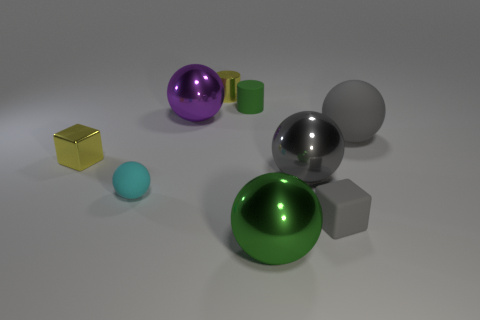What number of other objects are there of the same material as the big green sphere?
Your answer should be compact. 4. Do the big metallic object to the left of the large green shiny thing and the large object that is in front of the big gray shiny sphere have the same shape?
Your answer should be very brief. Yes. What is the color of the tiny cube to the right of the yellow shiny thing that is in front of the tiny cylinder that is behind the matte cylinder?
Give a very brief answer. Gray. What number of other objects are the same color as the small rubber ball?
Provide a succinct answer. 0. Are there fewer green cylinders than tiny yellow things?
Keep it short and to the point. Yes. What is the color of the metal object that is both to the right of the purple ball and behind the large gray matte object?
Provide a short and direct response. Yellow. There is a small cyan object that is the same shape as the large matte thing; what is it made of?
Ensure brevity in your answer.  Rubber. Is the number of big balls greater than the number of large yellow metal balls?
Your answer should be compact. Yes. There is a ball that is in front of the gray shiny sphere and to the right of the tiny cyan matte ball; what size is it?
Make the answer very short. Large. The small gray thing has what shape?
Offer a terse response. Cube. 